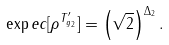Convert formula to latex. <formula><loc_0><loc_0><loc_500><loc_500>\exp e c [ \rho ^ { T ^ { \prime } _ { g _ { 2 } } } ] = \left ( \sqrt { 2 } \right ) ^ { \Delta _ { 2 } } .</formula> 